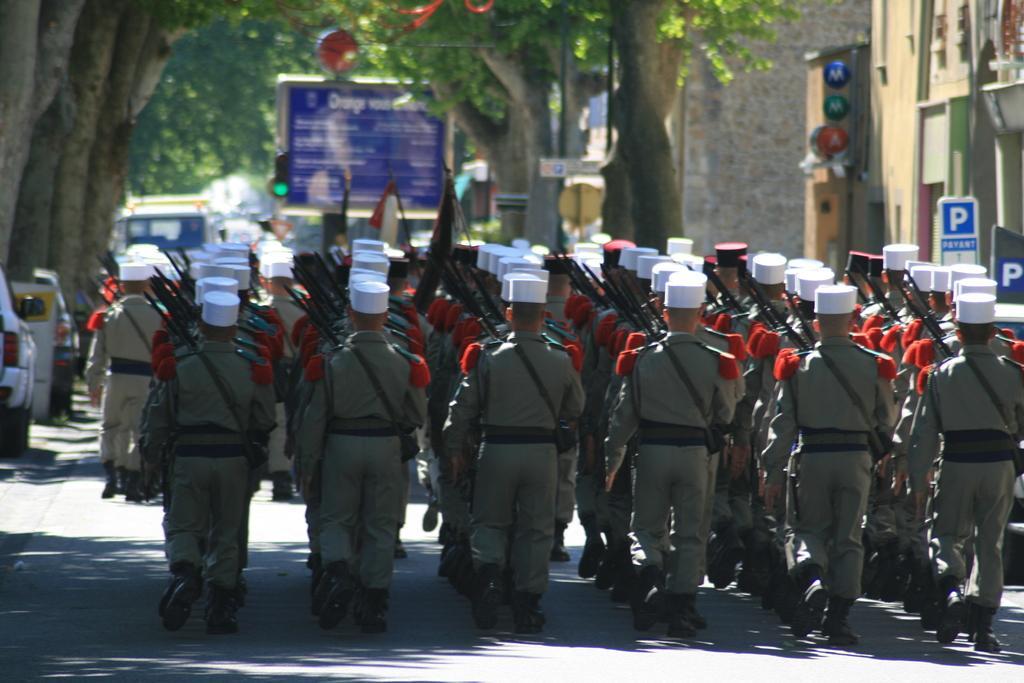Describe this image in one or two sentences. In the picture I can see a group of people are walking on the road. These people are wearing uniforms and some other objects. In the background I can see buildings, trees, vehicles and some other objects. 